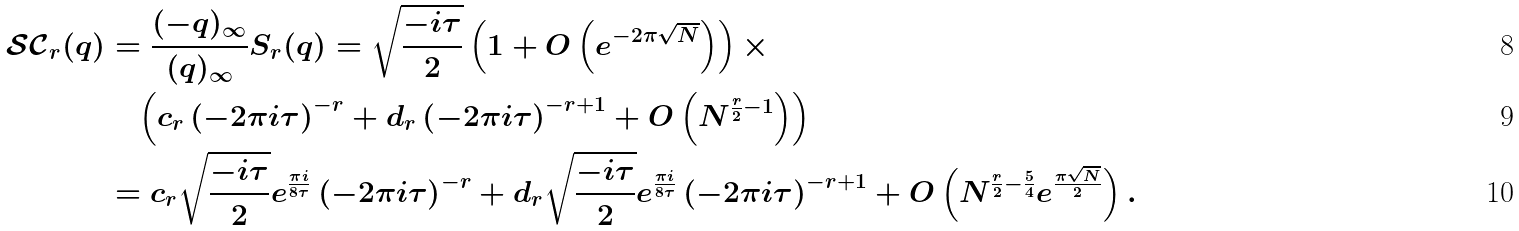<formula> <loc_0><loc_0><loc_500><loc_500>\mathcal { S C } _ { r } ( q ) & = \frac { ( - q ) _ { \infty } } { ( q ) _ { \infty } } S _ { r } ( q ) = \sqrt { \frac { - i \tau } { 2 } } \left ( 1 + O \left ( e ^ { - 2 \pi \sqrt { N } } \right ) \right ) \times \\ & \quad \left ( c _ { r } \left ( - 2 \pi i \tau \right ) ^ { - r } + d _ { r } \left ( - 2 \pi i \tau \right ) ^ { - r + 1 } + O \left ( N ^ { \frac { r } { 2 } - 1 } \right ) \right ) \\ & = c _ { r } \sqrt { \frac { - i \tau } { 2 } } e ^ { \frac { \pi i } { 8 \tau } } \left ( - 2 \pi i \tau \right ) ^ { - r } + d _ { r } \sqrt { \frac { - i \tau } { 2 } } e ^ { \frac { \pi i } { 8 \tau } } \left ( - 2 \pi i \tau \right ) ^ { - r + 1 } + O \left ( N ^ { \frac { r } { 2 } - \frac { 5 } { 4 } } e ^ { \frac { \pi \sqrt { N } } { 2 } } \right ) .</formula> 